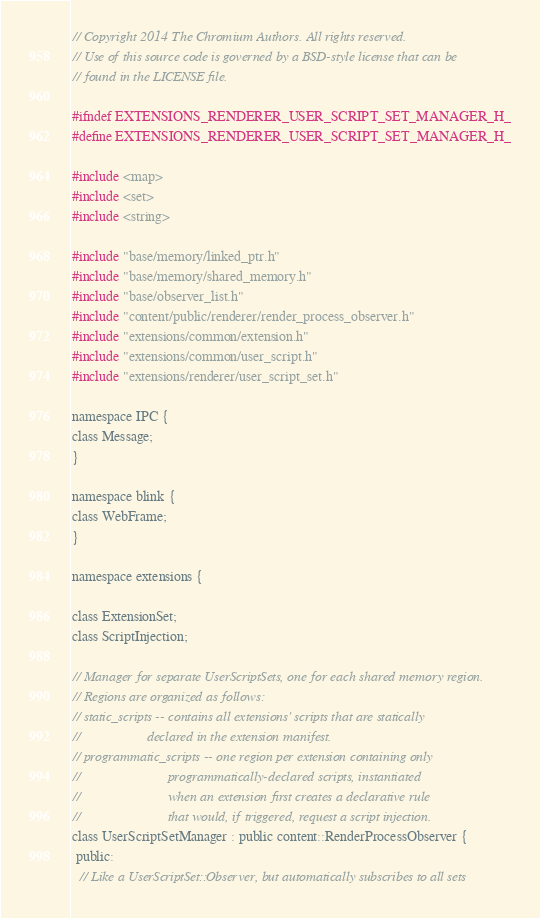<code> <loc_0><loc_0><loc_500><loc_500><_C_>// Copyright 2014 The Chromium Authors. All rights reserved.
// Use of this source code is governed by a BSD-style license that can be
// found in the LICENSE file.

#ifndef EXTENSIONS_RENDERER_USER_SCRIPT_SET_MANAGER_H_
#define EXTENSIONS_RENDERER_USER_SCRIPT_SET_MANAGER_H_

#include <map>
#include <set>
#include <string>

#include "base/memory/linked_ptr.h"
#include "base/memory/shared_memory.h"
#include "base/observer_list.h"
#include "content/public/renderer/render_process_observer.h"
#include "extensions/common/extension.h"
#include "extensions/common/user_script.h"
#include "extensions/renderer/user_script_set.h"

namespace IPC {
class Message;
}

namespace blink {
class WebFrame;
}

namespace extensions {

class ExtensionSet;
class ScriptInjection;

// Manager for separate UserScriptSets, one for each shared memory region.
// Regions are organized as follows:
// static_scripts -- contains all extensions' scripts that are statically
//                   declared in the extension manifest.
// programmatic_scripts -- one region per extension containing only
//                         programmatically-declared scripts, instantiated
//                         when an extension first creates a declarative rule
//                         that would, if triggered, request a script injection.
class UserScriptSetManager : public content::RenderProcessObserver {
 public:
  // Like a UserScriptSet::Observer, but automatically subscribes to all sets</code> 